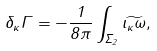Convert formula to latex. <formula><loc_0><loc_0><loc_500><loc_500>\delta _ { \kappa } \Gamma = - { \frac { 1 } { 8 \pi } } \int _ { \Sigma _ { 2 } } \widetilde { \iota _ { \kappa } \omega } ,</formula> 